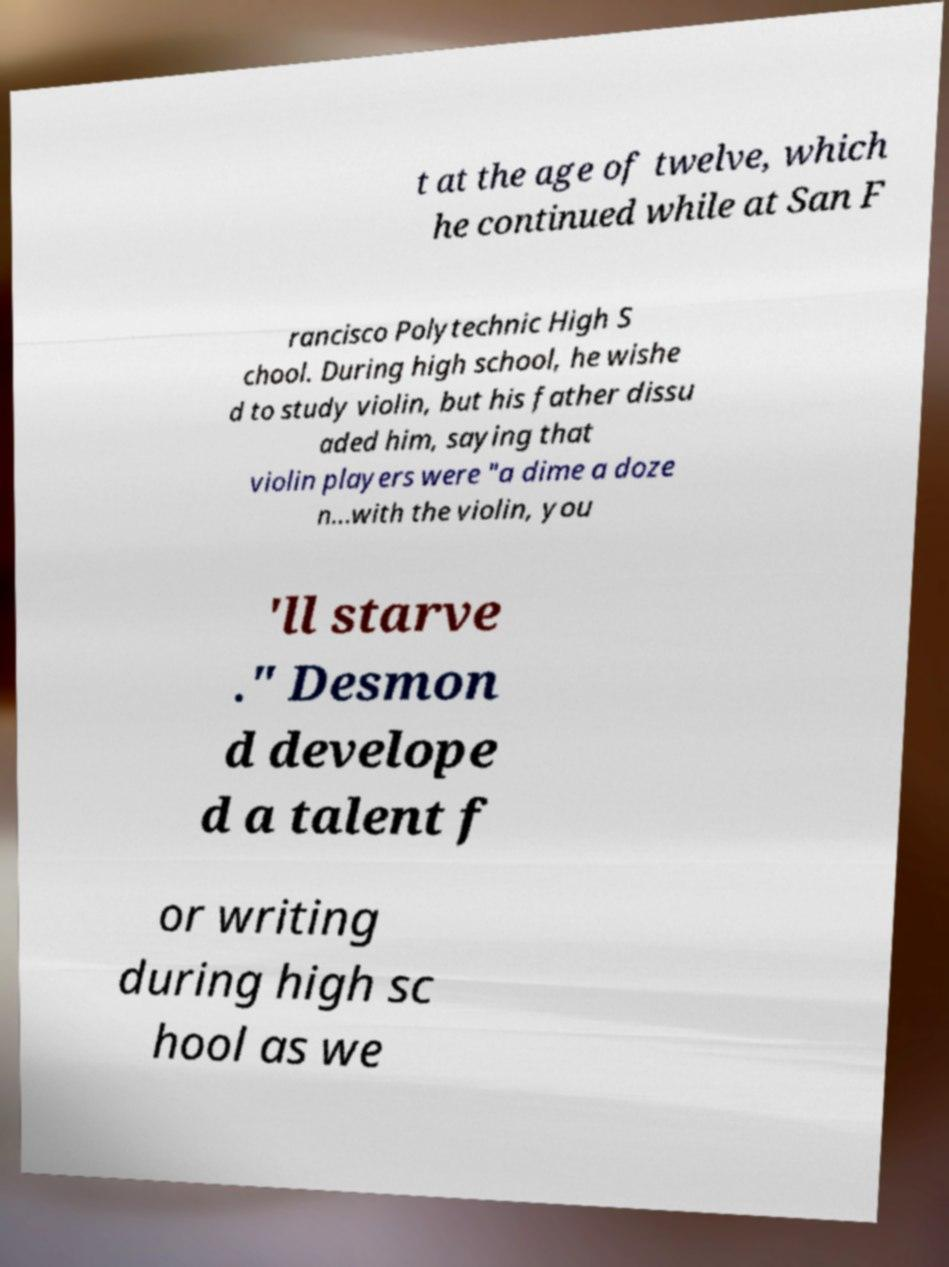Can you read and provide the text displayed in the image?This photo seems to have some interesting text. Can you extract and type it out for me? t at the age of twelve, which he continued while at San F rancisco Polytechnic High S chool. During high school, he wishe d to study violin, but his father dissu aded him, saying that violin players were "a dime a doze n...with the violin, you 'll starve ." Desmon d develope d a talent f or writing during high sc hool as we 